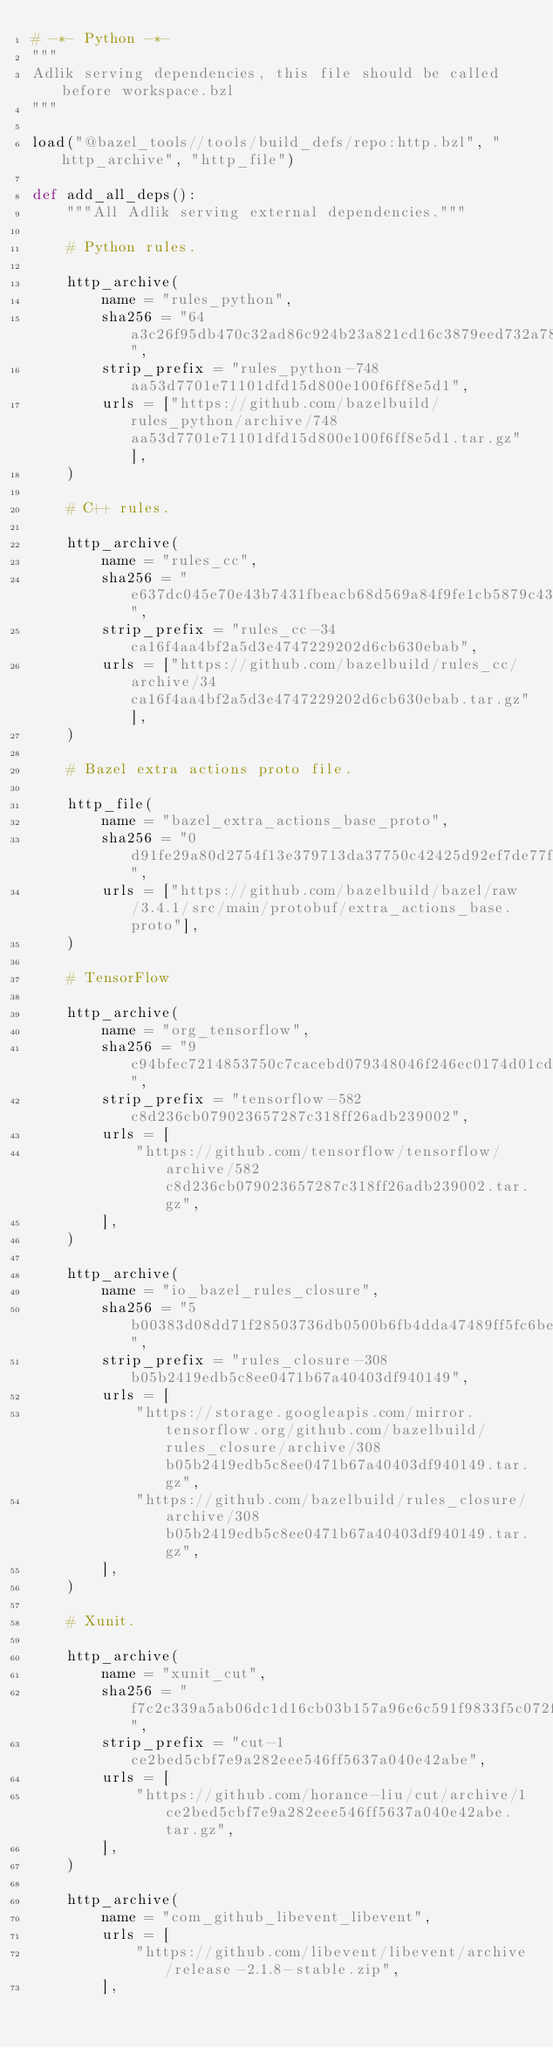Convert code to text. <code><loc_0><loc_0><loc_500><loc_500><_Python_># -*- Python -*-
"""
Adlik serving dependencies, this file should be called before workspace.bzl
"""

load("@bazel_tools//tools/build_defs/repo:http.bzl", "http_archive", "http_file")

def add_all_deps():
    """All Adlik serving external dependencies."""

    # Python rules.

    http_archive(
        name = "rules_python",
        sha256 = "64a3c26f95db470c32ad86c924b23a821cd16c3879eed732a7841779a32a60f8",
        strip_prefix = "rules_python-748aa53d7701e71101dfd15d800e100f6ff8e5d1",
        urls = ["https://github.com/bazelbuild/rules_python/archive/748aa53d7701e71101dfd15d800e100f6ff8e5d1.tar.gz"],
    )

    # C++ rules.

    http_archive(
        name = "rules_cc",
        sha256 = "e637dc045e70e43b7431fbeacb68d569a84f9fe1cb5879c432aa0855097dce57",
        strip_prefix = "rules_cc-34ca16f4aa4bf2a5d3e4747229202d6cb630ebab",
        urls = ["https://github.com/bazelbuild/rules_cc/archive/34ca16f4aa4bf2a5d3e4747229202d6cb630ebab.tar.gz"],
    )

    # Bazel extra actions proto file.

    http_file(
        name = "bazel_extra_actions_base_proto",
        sha256 = "0d91fe29a80d2754f13e379713da37750c42425d92ef7de77f60acdb82479edc",
        urls = ["https://github.com/bazelbuild/bazel/raw/3.4.1/src/main/protobuf/extra_actions_base.proto"],
    )

    # TensorFlow

    http_archive(
        name = "org_tensorflow",
        sha256 = "9c94bfec7214853750c7cacebd079348046f246ec0174d01cd36eda375117628",
        strip_prefix = "tensorflow-582c8d236cb079023657287c318ff26adb239002",
        urls = [
            "https://github.com/tensorflow/tensorflow/archive/582c8d236cb079023657287c318ff26adb239002.tar.gz",
        ],
    )

    http_archive(
        name = "io_bazel_rules_closure",
        sha256 = "5b00383d08dd71f28503736db0500b6fb4dda47489ff5fc6bed42557c07c6ba9",
        strip_prefix = "rules_closure-308b05b2419edb5c8ee0471b67a40403df940149",
        urls = [
            "https://storage.googleapis.com/mirror.tensorflow.org/github.com/bazelbuild/rules_closure/archive/308b05b2419edb5c8ee0471b67a40403df940149.tar.gz",
            "https://github.com/bazelbuild/rules_closure/archive/308b05b2419edb5c8ee0471b67a40403df940149.tar.gz",
        ],
    )

    # Xunit.

    http_archive(
        name = "xunit_cut",
        sha256 = "f7c2c339a5ab06dc1d16cb03b157a96e6c591f9833f5c072f56af4a8f8013b53",
        strip_prefix = "cut-1ce2bed5cbf7e9a282eee546ff5637a040e42abe",
        urls = [
            "https://github.com/horance-liu/cut/archive/1ce2bed5cbf7e9a282eee546ff5637a040e42abe.tar.gz",
        ],
    )

    http_archive(
        name = "com_github_libevent_libevent",
        urls = [
            "https://github.com/libevent/libevent/archive/release-2.1.8-stable.zip",
        ],</code> 